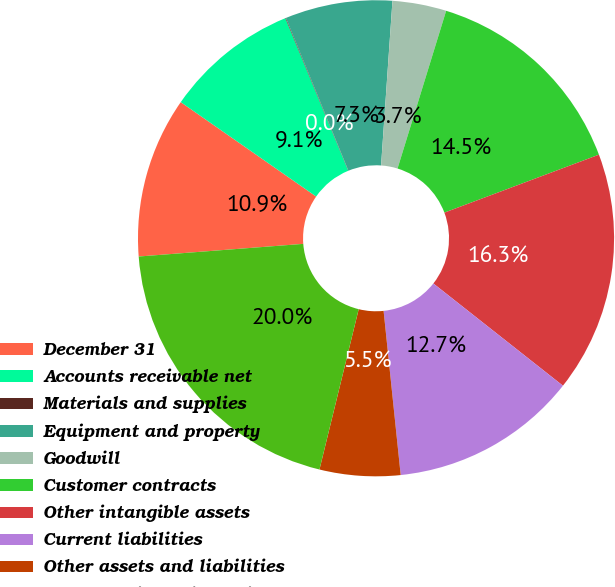Convert chart to OTSL. <chart><loc_0><loc_0><loc_500><loc_500><pie_chart><fcel>December 31<fcel>Accounts receivable net<fcel>Materials and supplies<fcel>Equipment and property<fcel>Goodwill<fcel>Customer contracts<fcel>Other intangible assets<fcel>Current liabilities<fcel>Other assets and liabilities<fcel>Total consideration paid<nl><fcel>10.91%<fcel>9.09%<fcel>0.04%<fcel>7.28%<fcel>3.66%<fcel>14.53%<fcel>16.34%<fcel>12.72%<fcel>5.47%<fcel>19.96%<nl></chart> 